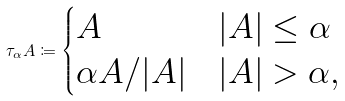Convert formula to latex. <formula><loc_0><loc_0><loc_500><loc_500>\tau _ { \alpha } A \coloneqq \begin{cases} A & | A | \leq \alpha \\ \alpha A / | A | & | A | > \alpha , \end{cases}</formula> 